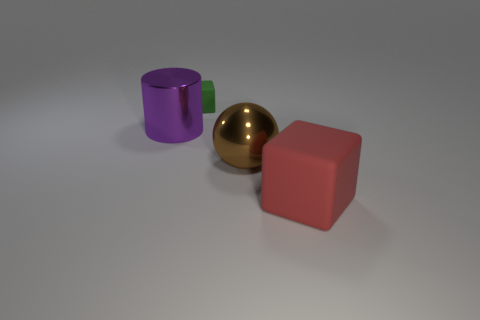Subtract all red cubes. How many cubes are left? 1 Add 3 big red blocks. How many objects exist? 7 Subtract 1 cubes. How many cubes are left? 1 Subtract all cylinders. How many objects are left? 3 Subtract all metal spheres. Subtract all brown shiny spheres. How many objects are left? 2 Add 2 red rubber cubes. How many red rubber cubes are left? 3 Add 2 big green matte cubes. How many big green matte cubes exist? 2 Subtract 0 blue cylinders. How many objects are left? 4 Subtract all yellow cylinders. Subtract all purple spheres. How many cylinders are left? 1 Subtract all brown spheres. How many red blocks are left? 1 